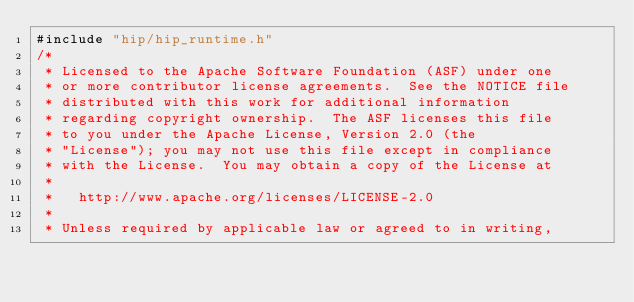<code> <loc_0><loc_0><loc_500><loc_500><_Cuda_>#include "hip/hip_runtime.h"
/*
 * Licensed to the Apache Software Foundation (ASF) under one
 * or more contributor license agreements.  See the NOTICE file
 * distributed with this work for additional information
 * regarding copyright ownership.  The ASF licenses this file
 * to you under the Apache License, Version 2.0 (the
 * "License"); you may not use this file except in compliance
 * with the License.  You may obtain a copy of the License at
 *
 *   http://www.apache.org/licenses/LICENSE-2.0
 *
 * Unless required by applicable law or agreed to in writing,</code> 